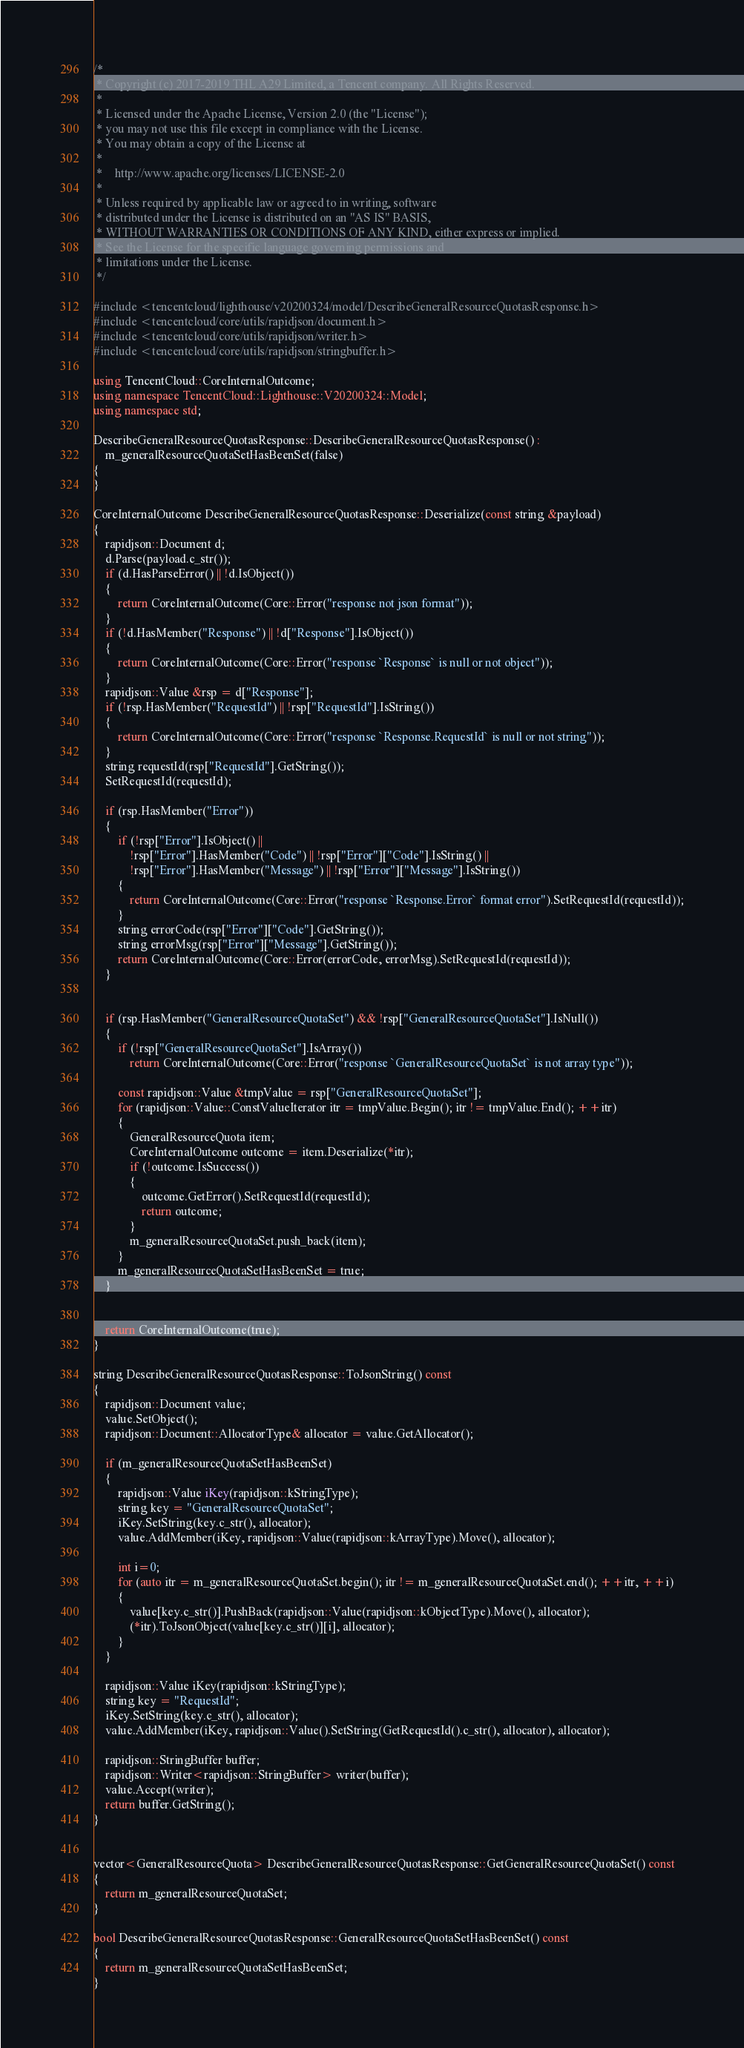Convert code to text. <code><loc_0><loc_0><loc_500><loc_500><_C++_>/*
 * Copyright (c) 2017-2019 THL A29 Limited, a Tencent company. All Rights Reserved.
 *
 * Licensed under the Apache License, Version 2.0 (the "License");
 * you may not use this file except in compliance with the License.
 * You may obtain a copy of the License at
 *
 *    http://www.apache.org/licenses/LICENSE-2.0
 *
 * Unless required by applicable law or agreed to in writing, software
 * distributed under the License is distributed on an "AS IS" BASIS,
 * WITHOUT WARRANTIES OR CONDITIONS OF ANY KIND, either express or implied.
 * See the License for the specific language governing permissions and
 * limitations under the License.
 */

#include <tencentcloud/lighthouse/v20200324/model/DescribeGeneralResourceQuotasResponse.h>
#include <tencentcloud/core/utils/rapidjson/document.h>
#include <tencentcloud/core/utils/rapidjson/writer.h>
#include <tencentcloud/core/utils/rapidjson/stringbuffer.h>

using TencentCloud::CoreInternalOutcome;
using namespace TencentCloud::Lighthouse::V20200324::Model;
using namespace std;

DescribeGeneralResourceQuotasResponse::DescribeGeneralResourceQuotasResponse() :
    m_generalResourceQuotaSetHasBeenSet(false)
{
}

CoreInternalOutcome DescribeGeneralResourceQuotasResponse::Deserialize(const string &payload)
{
    rapidjson::Document d;
    d.Parse(payload.c_str());
    if (d.HasParseError() || !d.IsObject())
    {
        return CoreInternalOutcome(Core::Error("response not json format"));
    }
    if (!d.HasMember("Response") || !d["Response"].IsObject())
    {
        return CoreInternalOutcome(Core::Error("response `Response` is null or not object"));
    }
    rapidjson::Value &rsp = d["Response"];
    if (!rsp.HasMember("RequestId") || !rsp["RequestId"].IsString())
    {
        return CoreInternalOutcome(Core::Error("response `Response.RequestId` is null or not string"));
    }
    string requestId(rsp["RequestId"].GetString());
    SetRequestId(requestId);

    if (rsp.HasMember("Error"))
    {
        if (!rsp["Error"].IsObject() ||
            !rsp["Error"].HasMember("Code") || !rsp["Error"]["Code"].IsString() ||
            !rsp["Error"].HasMember("Message") || !rsp["Error"]["Message"].IsString())
        {
            return CoreInternalOutcome(Core::Error("response `Response.Error` format error").SetRequestId(requestId));
        }
        string errorCode(rsp["Error"]["Code"].GetString());
        string errorMsg(rsp["Error"]["Message"].GetString());
        return CoreInternalOutcome(Core::Error(errorCode, errorMsg).SetRequestId(requestId));
    }


    if (rsp.HasMember("GeneralResourceQuotaSet") && !rsp["GeneralResourceQuotaSet"].IsNull())
    {
        if (!rsp["GeneralResourceQuotaSet"].IsArray())
            return CoreInternalOutcome(Core::Error("response `GeneralResourceQuotaSet` is not array type"));

        const rapidjson::Value &tmpValue = rsp["GeneralResourceQuotaSet"];
        for (rapidjson::Value::ConstValueIterator itr = tmpValue.Begin(); itr != tmpValue.End(); ++itr)
        {
            GeneralResourceQuota item;
            CoreInternalOutcome outcome = item.Deserialize(*itr);
            if (!outcome.IsSuccess())
            {
                outcome.GetError().SetRequestId(requestId);
                return outcome;
            }
            m_generalResourceQuotaSet.push_back(item);
        }
        m_generalResourceQuotaSetHasBeenSet = true;
    }


    return CoreInternalOutcome(true);
}

string DescribeGeneralResourceQuotasResponse::ToJsonString() const
{
    rapidjson::Document value;
    value.SetObject();
    rapidjson::Document::AllocatorType& allocator = value.GetAllocator();

    if (m_generalResourceQuotaSetHasBeenSet)
    {
        rapidjson::Value iKey(rapidjson::kStringType);
        string key = "GeneralResourceQuotaSet";
        iKey.SetString(key.c_str(), allocator);
        value.AddMember(iKey, rapidjson::Value(rapidjson::kArrayType).Move(), allocator);

        int i=0;
        for (auto itr = m_generalResourceQuotaSet.begin(); itr != m_generalResourceQuotaSet.end(); ++itr, ++i)
        {
            value[key.c_str()].PushBack(rapidjson::Value(rapidjson::kObjectType).Move(), allocator);
            (*itr).ToJsonObject(value[key.c_str()][i], allocator);
        }
    }

    rapidjson::Value iKey(rapidjson::kStringType);
    string key = "RequestId";
    iKey.SetString(key.c_str(), allocator);
    value.AddMember(iKey, rapidjson::Value().SetString(GetRequestId().c_str(), allocator), allocator);
    
    rapidjson::StringBuffer buffer;
    rapidjson::Writer<rapidjson::StringBuffer> writer(buffer);
    value.Accept(writer);
    return buffer.GetString();
}


vector<GeneralResourceQuota> DescribeGeneralResourceQuotasResponse::GetGeneralResourceQuotaSet() const
{
    return m_generalResourceQuotaSet;
}

bool DescribeGeneralResourceQuotasResponse::GeneralResourceQuotaSetHasBeenSet() const
{
    return m_generalResourceQuotaSetHasBeenSet;
}


</code> 